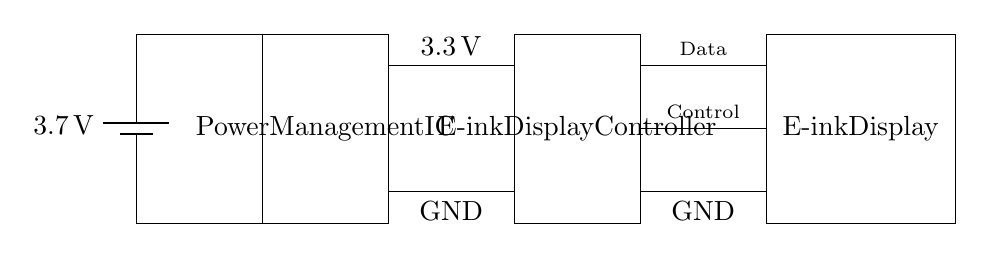What is the voltage of the battery? The circuit shows a battery labeled with a voltage of 3.7 volts, indicating the power source for the circuit.
Answer: 3.7 volts What type of component is the block labeled as "Power Management IC"? The circuit diagram shows a rectangular block labeled "Power Management IC," which is a standard component used to manage power distribution and voltage regulation in electronic devices.
Answer: Integrated circuit What is the output voltage from the Power Management IC to the E-ink Display Controller? The connection from the Power Management IC to the E-ink Display Controller is labeled with an output voltage of 3.3 volts, indicating the regulated voltage supplied to the controller.
Answer: 3.3 volts How many grounds are there in this circuit? The circuit shows two ground connections: one is connected to the Power Management IC and the other to the E-ink Display Controller, resulting in two ground points in total.
Answer: Two What are the two types of signals coming from the E-ink Display Controller to the E-ink Display? The E-ink Display Controller is connected to the E-ink Display via two labeled lines: "Data" and "Control," indicating that it controls both types of signals sent to the display for rendering images and updates.
Answer: Data and Control What is the main function of the Power Management IC in this circuit? The Power Management IC regulates and distributes the voltage from the battery to ensure that the components of the circuit receive stable and appropriate power levels, essential for their operation.
Answer: Voltage regulation 